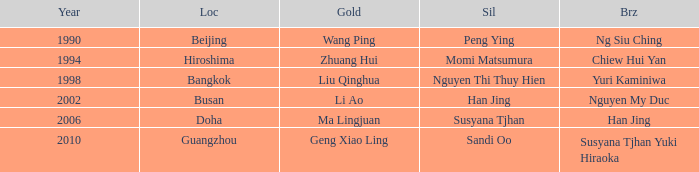What's the Bronze with the Year of 1998? Yuri Kaminiwa. 